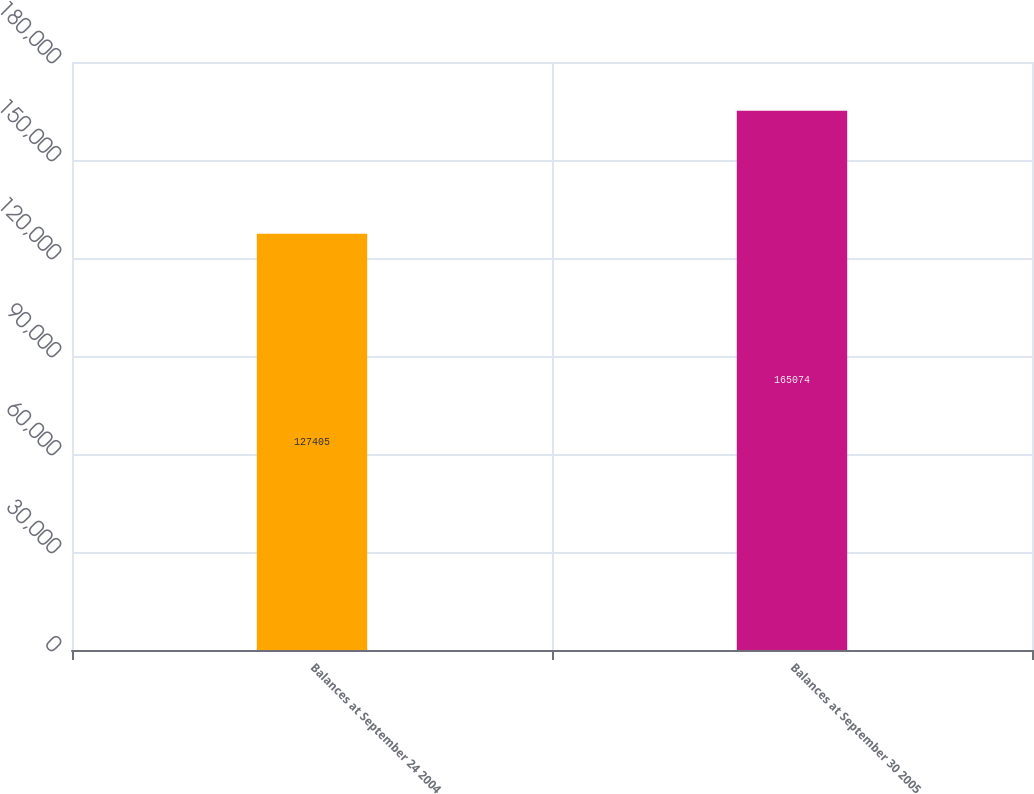Convert chart to OTSL. <chart><loc_0><loc_0><loc_500><loc_500><bar_chart><fcel>Balances at September 24 2004<fcel>Balances at September 30 2005<nl><fcel>127405<fcel>165074<nl></chart> 